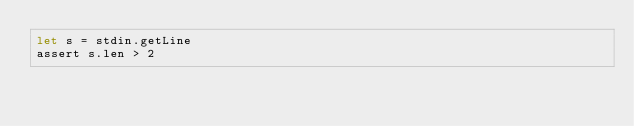Convert code to text. <code><loc_0><loc_0><loc_500><loc_500><_Nim_>let s = stdin.getLine
assert s.len > 2</code> 